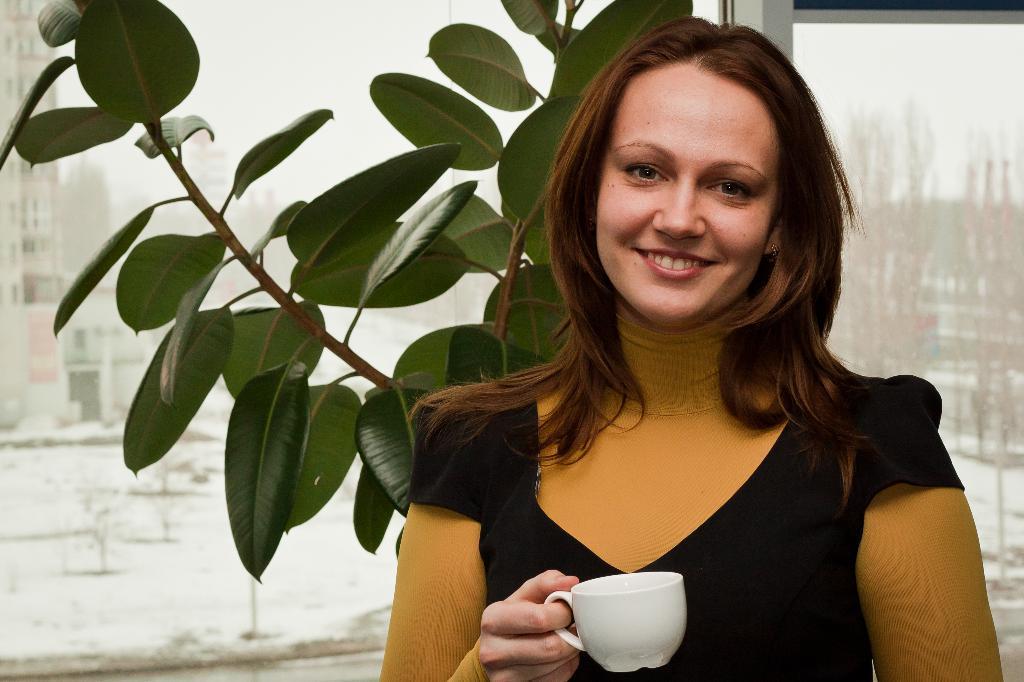Please provide a concise description of this image. In this image i can see a woman holding cup and smiling at the back ground i can see a plant and a window. 